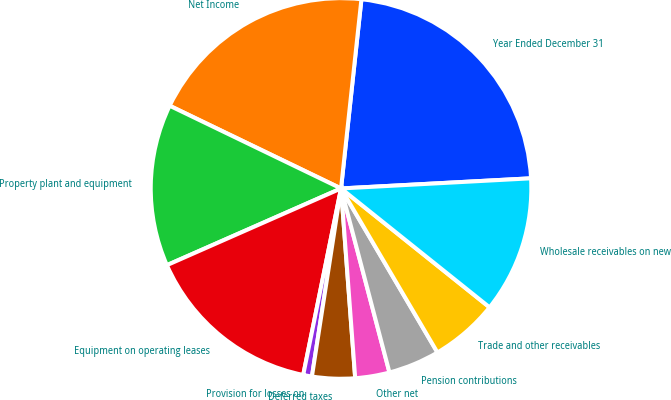<chart> <loc_0><loc_0><loc_500><loc_500><pie_chart><fcel>Year Ended December 31<fcel>Net Income<fcel>Property plant and equipment<fcel>Equipment on operating leases<fcel>Provision for losses on<fcel>Deferred taxes<fcel>Other net<fcel>Pension contributions<fcel>Trade and other receivables<fcel>Wholesale receivables on new<nl><fcel>22.44%<fcel>19.55%<fcel>13.76%<fcel>15.21%<fcel>0.74%<fcel>3.63%<fcel>2.91%<fcel>4.36%<fcel>5.8%<fcel>11.59%<nl></chart> 